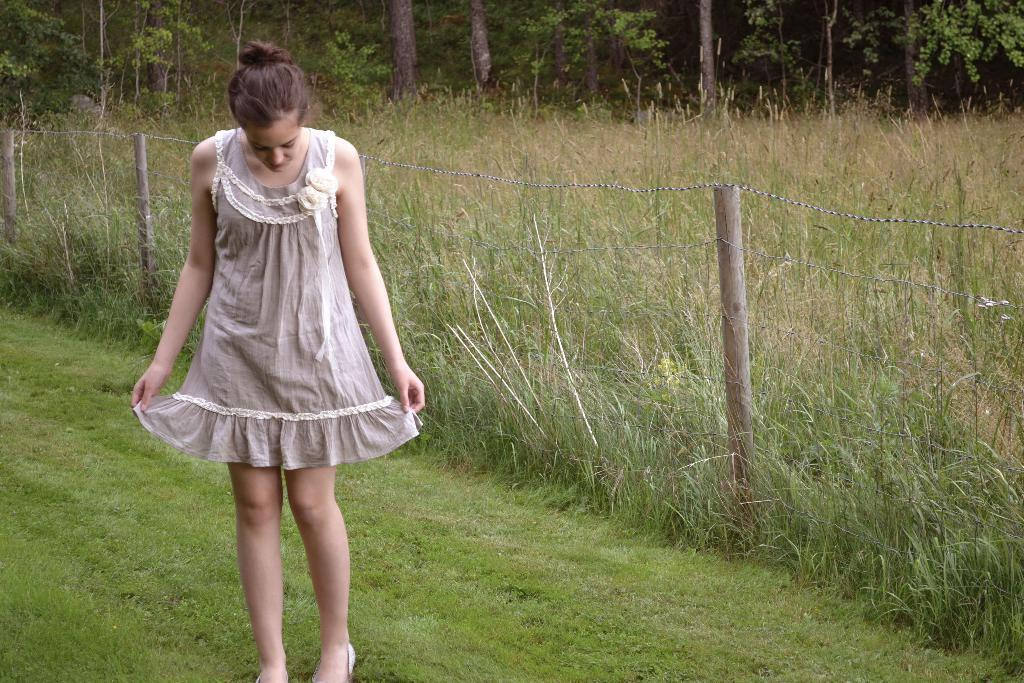What is the main subject of the image? There is a woman standing in the image. What type of natural elements can be seen in the image? There are plants and trees in the image. What kind of barrier is present in the image? There is a rope fence in the image. What type of prose is the woman reading in the image? There is no indication in the image that the woman is reading any prose. What type of guitar can be seen in the image? There is no guitar present in the image. 